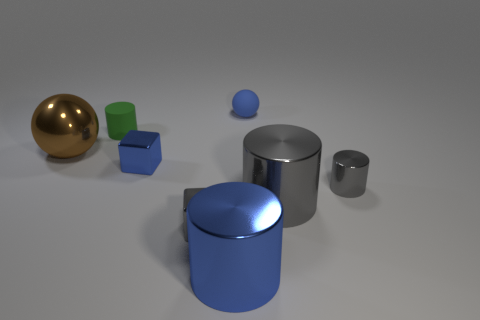Are there more cubes that are behind the small gray shiny cylinder than brown spheres right of the small blue ball?
Provide a short and direct response. Yes. Is the green matte object the same size as the blue shiny block?
Keep it short and to the point. Yes. What color is the other tiny object that is the same shape as the brown metal thing?
Give a very brief answer. Blue. How many rubber objects have the same color as the shiny sphere?
Your answer should be very brief. 0. Is the number of tiny matte cylinders that are on the left side of the small green rubber object greater than the number of large purple metal things?
Give a very brief answer. No. The small cylinder that is in front of the ball that is to the left of the green matte thing is what color?
Keep it short and to the point. Gray. How many objects are either blue things that are behind the large brown metallic ball or big shiny things that are in front of the gray shiny block?
Provide a short and direct response. 2. The rubber cylinder is what color?
Your answer should be compact. Green. What number of blue blocks are made of the same material as the large brown thing?
Ensure brevity in your answer.  1. Is the number of big metal cylinders greater than the number of purple rubber things?
Make the answer very short. Yes. 